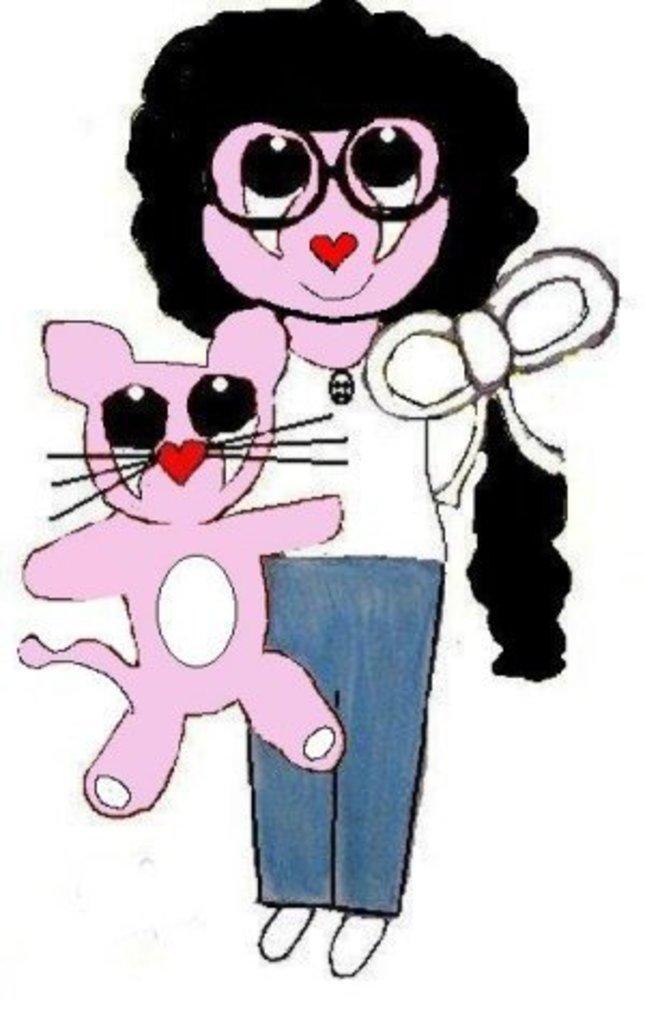Please provide a concise description of this image. In this image I can see a person, cat and some objects. This image looks like a painting. 